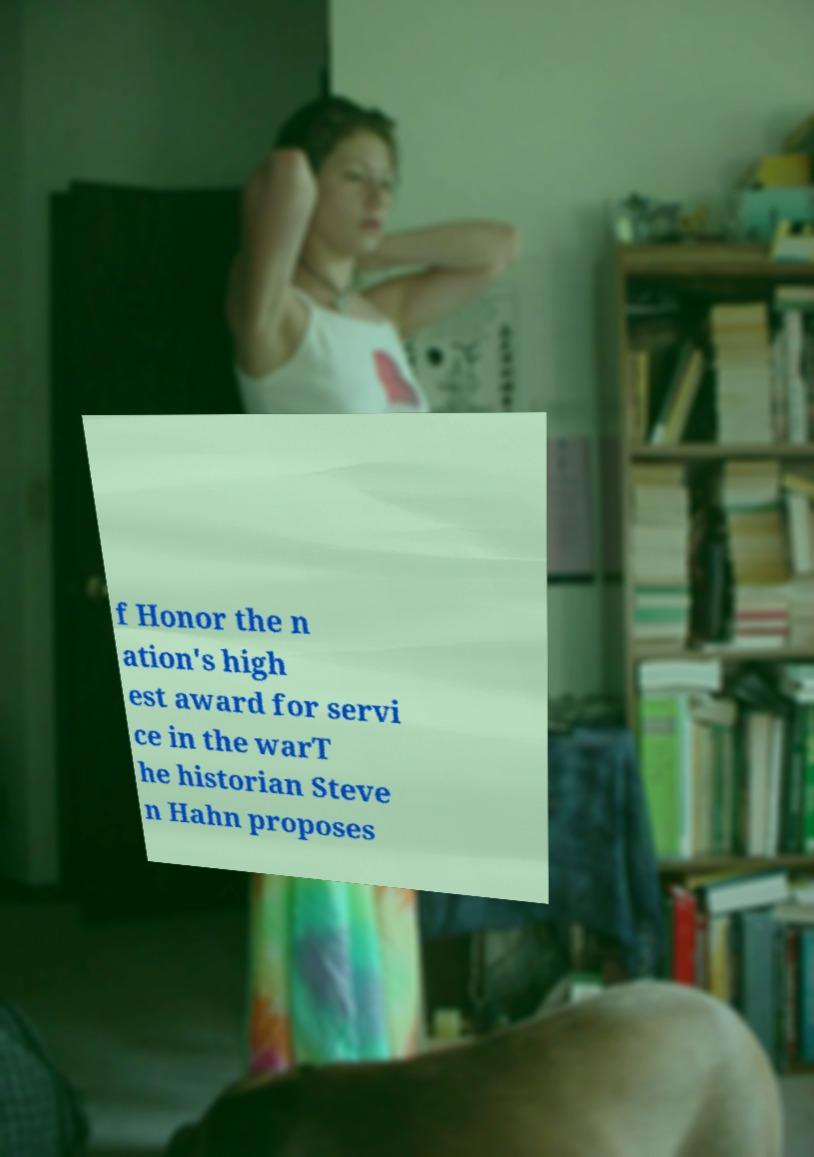Could you extract and type out the text from this image? f Honor the n ation's high est award for servi ce in the warT he historian Steve n Hahn proposes 